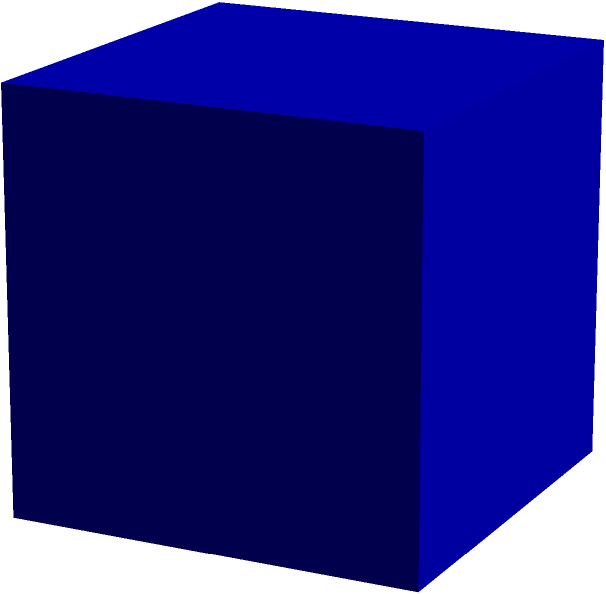A cube-shaped tissue box has an edge length of 5 inches. If you need to cover the entire box with a decorative wrap to make it more visually appealing for your visually impaired client, how much wrapping material would you need in square inches? To find the surface area of a cube, we need to follow these steps:

1. Recall the formula for the surface area of a cube:
   Surface Area = $6a^2$, where $a$ is the length of one edge.

2. In this case, the edge length $a = 5$ inches.

3. Substitute this value into the formula:
   Surface Area = $6 * (5\text{ in})^2$

4. Calculate the result:
   Surface Area = $6 * 25\text{ in}^2 = 150\text{ in}^2$

Therefore, you would need 150 square inches of wrapping material to cover the entire tissue box.
Answer: 150 square inches 